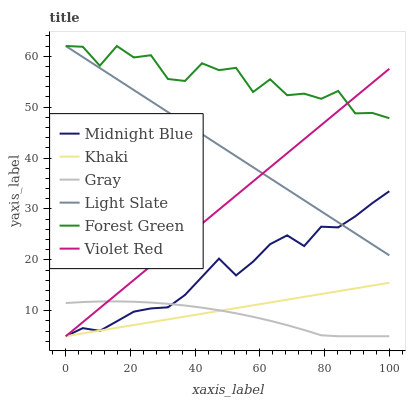Does Gray have the minimum area under the curve?
Answer yes or no. Yes. Does Forest Green have the maximum area under the curve?
Answer yes or no. Yes. Does Violet Red have the minimum area under the curve?
Answer yes or no. No. Does Violet Red have the maximum area under the curve?
Answer yes or no. No. Is Khaki the smoothest?
Answer yes or no. Yes. Is Forest Green the roughest?
Answer yes or no. Yes. Is Violet Red the smoothest?
Answer yes or no. No. Is Violet Red the roughest?
Answer yes or no. No. Does Gray have the lowest value?
Answer yes or no. Yes. Does Light Slate have the lowest value?
Answer yes or no. No. Does Forest Green have the highest value?
Answer yes or no. Yes. Does Violet Red have the highest value?
Answer yes or no. No. Is Khaki less than Forest Green?
Answer yes or no. Yes. Is Forest Green greater than Khaki?
Answer yes or no. Yes. Does Light Slate intersect Violet Red?
Answer yes or no. Yes. Is Light Slate less than Violet Red?
Answer yes or no. No. Is Light Slate greater than Violet Red?
Answer yes or no. No. Does Khaki intersect Forest Green?
Answer yes or no. No. 